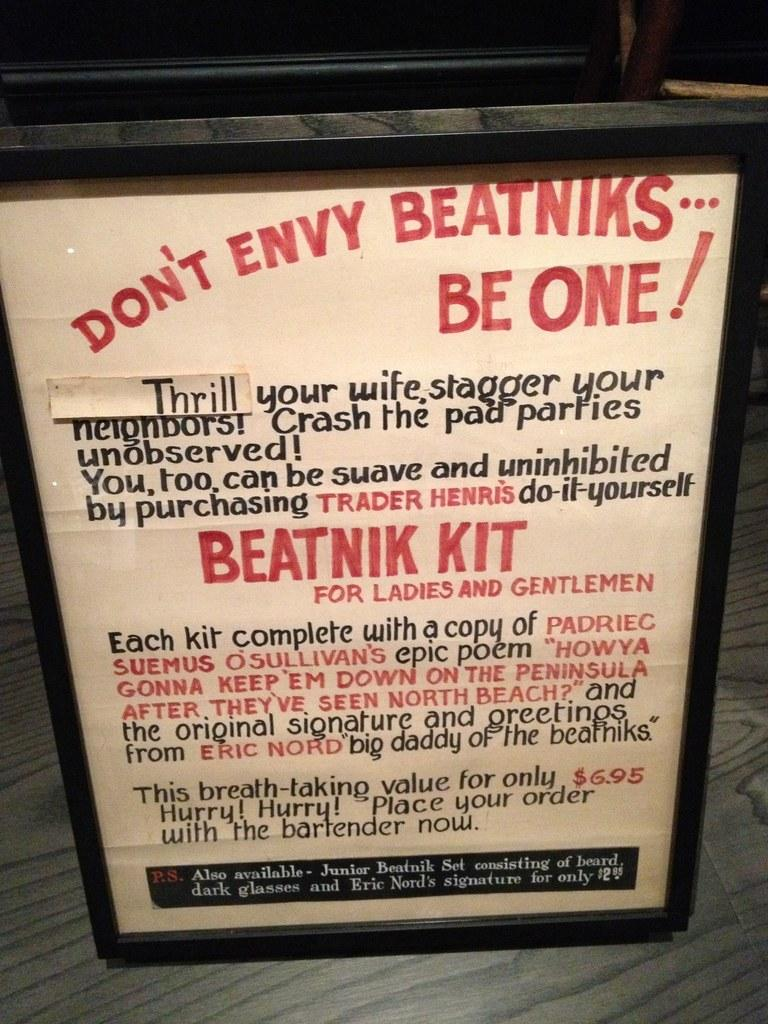<image>
Relay a brief, clear account of the picture shown. Vintage advertisement poster plaque stating Don't Envy Beatniks...be one! in red lettering. 